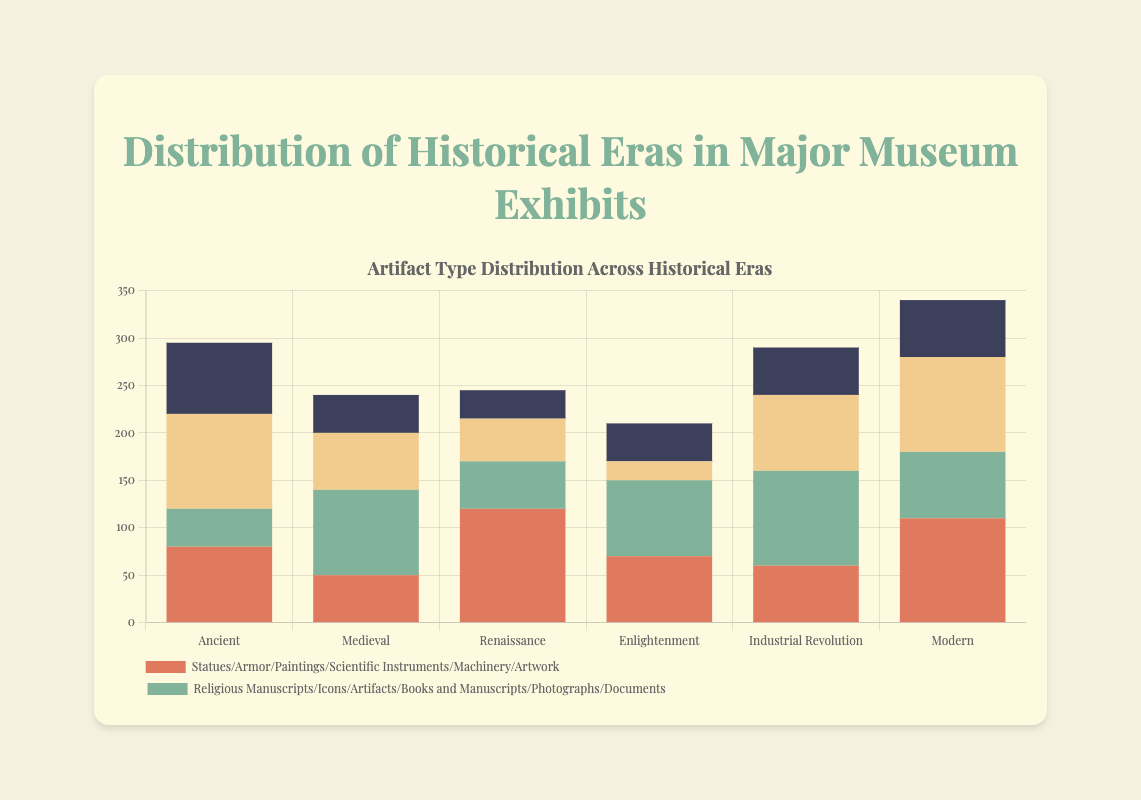What era has the highest number of coins displayed? By looking at the bar corresponding to coins in each era, 'Ancient' has the tallest bar, indicating 100 coins.
Answer: Ancient Which era has more religious artifacts: Medieval or Renaissance? The 'Religious Manuscripts/Icons/Artifacts' label corresponds to 90 in Medieval (Religious Icons) and 50 in Renaissance (Religious Artifacts).
Answer: Medieval What is the combined total of coins from the Enlightenment and Modern eras? Add the number of coins in the Enlightenment era (20) and in the Modern era (100): 20 + 100 = 120.
Answer: 120 Which type of artifact is most common in the Renaissance era? Observe the heights of the bars for each artifact type in the Renaissance era; 'Paintings' is the tallest with 120.
Answer: Paintings Which era has the least amount of personal items/personal artifacts? Out of the eras shown, the shortest bar for 'Personal Items/Personal Artifacts' is in the Enlightenment era with 40 (Textiles).
Answer: Enlightenment What is the total number of ceramics in all eras? The dataset only shows ceramics in the Ancient era with 75. Thus, the total is 75.
Answer: 75 Compare the number of religious manuscripts/icons/artifacts in the Ancient and Enlightenment eras. Which era has fewer? Ancient has 40 (Religious Manuscripts), and Enlightenment has 80 (Books and Manuscripts). Ancients have fewer.
Answer: Ancient What is the total number of statues/armor/paintings/scientific instruments/machinery/artwork in the Industrial Revolution and Modern eras combined? Sum the values of these artifacts: Industrial Revolution (Machinery: 60) + Modern (Artwork: 110); 60 + 110 = 170.
Answer: 170 Which artifact type has the smallest total when all historical eras are combined? Sum each artifact type across the eras; 'Ceramics/Coin/Instruments/Textiles/Personal Items/Personal Artifacts' has the smallest total with sums of (75 + 40 + 30 + 40 + 50 + 60) = 295.
Answer: Ceramics/Coin/Instruments/Textiles/Personal Items/Personal Artifacts Compare the number of scientific instruments in the Enlightenment era to the number of paintings in the Renaissance era. Which is greater and by how much? The Enlightenment era has 70 scientific instruments, while the Renaissance era has 120 paintings. The difference is 120 - 70 = 50.
Answer: Renaissance by 50 